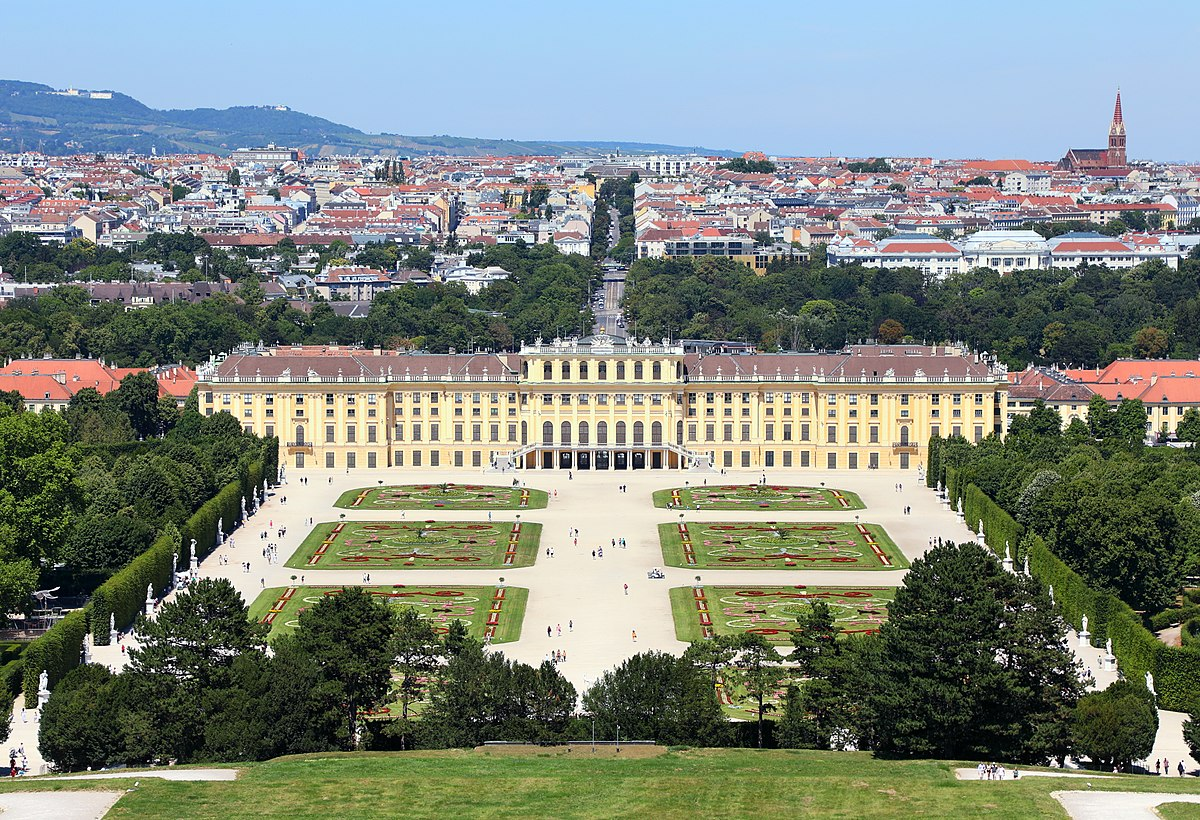Can you explain the historical significance of Schonbrunn Palace? Schonbrunn Palace was built in the 17th century and served as the summer residence of the Habsburg emperors. It's celebrated not only for its Baroque architecture but also for its historical role in the political and cultural engagements of the Habsburg monarchy. Throughout its history, the palace has hosted numerous historical figures and events, such as the congress of Vienna in 1814-15 that reshaped Europe after Napoleon's defeat. Moreover, its cultural significance is palpable, having been a center for orchestral music, with legends like Mozart performing within its walls. 